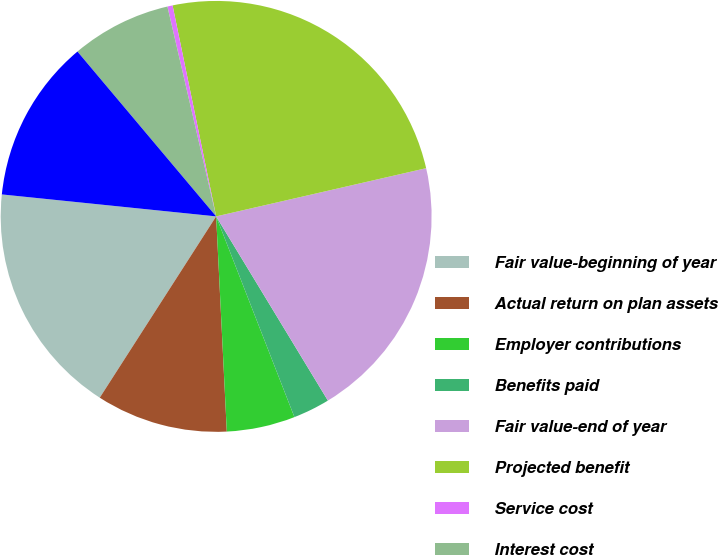Convert chart. <chart><loc_0><loc_0><loc_500><loc_500><pie_chart><fcel>Fair value-beginning of year<fcel>Actual return on plan assets<fcel>Employer contributions<fcel>Benefits paid<fcel>Fair value-end of year<fcel>Projected benefit<fcel>Service cost<fcel>Interest cost<fcel>Actuarial loss (gain)<nl><fcel>17.54%<fcel>9.87%<fcel>5.13%<fcel>2.76%<fcel>19.91%<fcel>24.65%<fcel>0.39%<fcel>7.5%<fcel>12.24%<nl></chart> 